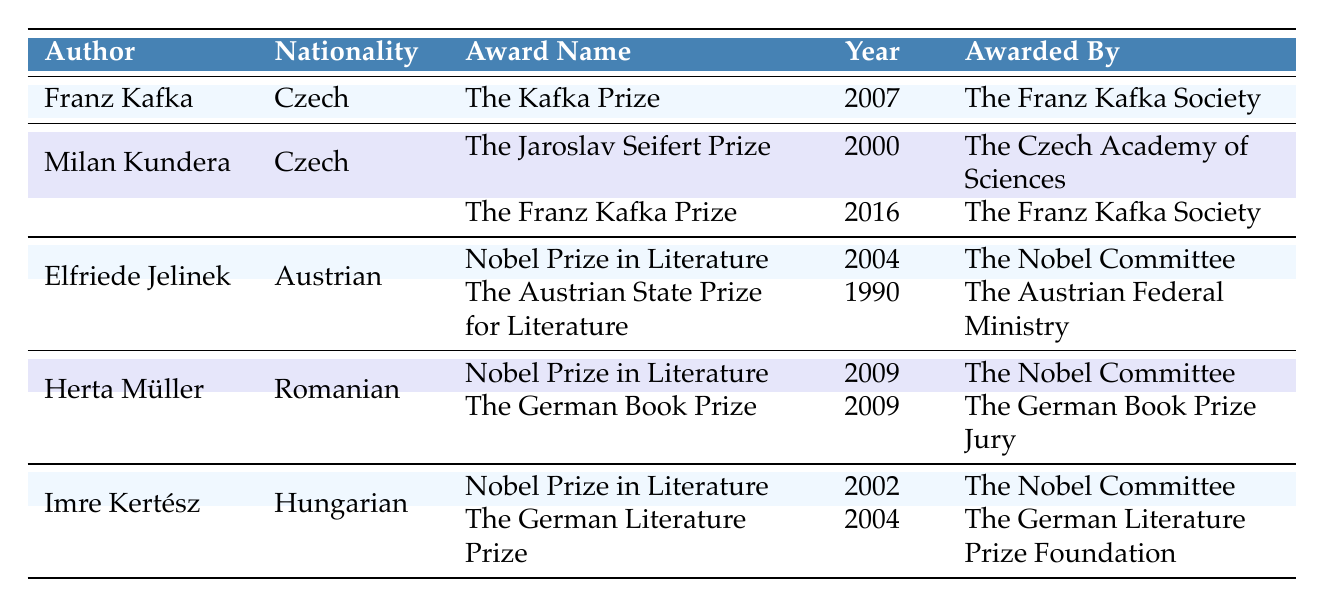What award did Elfriede Jelinek receive in 2004? According to the table, Elfriede Jelinek received the Nobel Prize in Literature in 2004. This information can be found in the row dedicated to her under the "Award Name" and "Year" columns.
Answer: Nobel Prize in Literature How many awards did Milan Kundera receive according to the table? The table lists two awards received by Milan Kundera: The Jaroslav Seifert Prize in 2000 and The Franz Kafka Prize in 2016. Thus, the total number of awards listed for him is two.
Answer: 2 Did Herta Müller receive the Nobel Prize in Literature? Yes, the table shows that Herta Müller received the Nobel Prize in Literature in 2009, which is highlighted in her row under the "Award Name" column.
Answer: Yes Which author has received the most awards according to the table? By looking at the table, Elfriede Jelinek, Herta Müller, and Imre Kertész each received two awards listed, while Franz Kafka and Milan Kundera received one and two respectively. Therefore, Elfriede Jelinek, Herta Müller, and Imre Kertész are tied with the most awards.
Answer: Elfriede Jelinek, Herta Müller, and Imre Kertész (3 authors) In which year did Imre Kertész receive the Nobel Prize in Literature? The table specifies that Imre Kertész received the Nobel Prize in Literature in 2002, as seen in his row under the "Year" column.
Answer: 2002 What is the nationality of the author who received The Austrian State Prize for Literature? The author who received The Austrian State Prize for Literature is Elfriede Jelinek, and she is from Austria, which is indicated in the "Nationality" column for her row.
Answer: Austrian How many awards listed were given in the year 2009? The table shows two awards given in 2009. Herta Müller received the Nobel Prize in Literature, and she also received The German Book Prize in the same year. The total count of awards in this year is double.
Answer: 2 Which award was given by The Nobel Committee? The table shows that the Nobel Prize in Literature was awarded by The Nobel Committee, appearing multiple times for different authors (Herta Müller, Elfriede Jelinek, and Imre Kertész).
Answer: Nobel Prize in Literature 